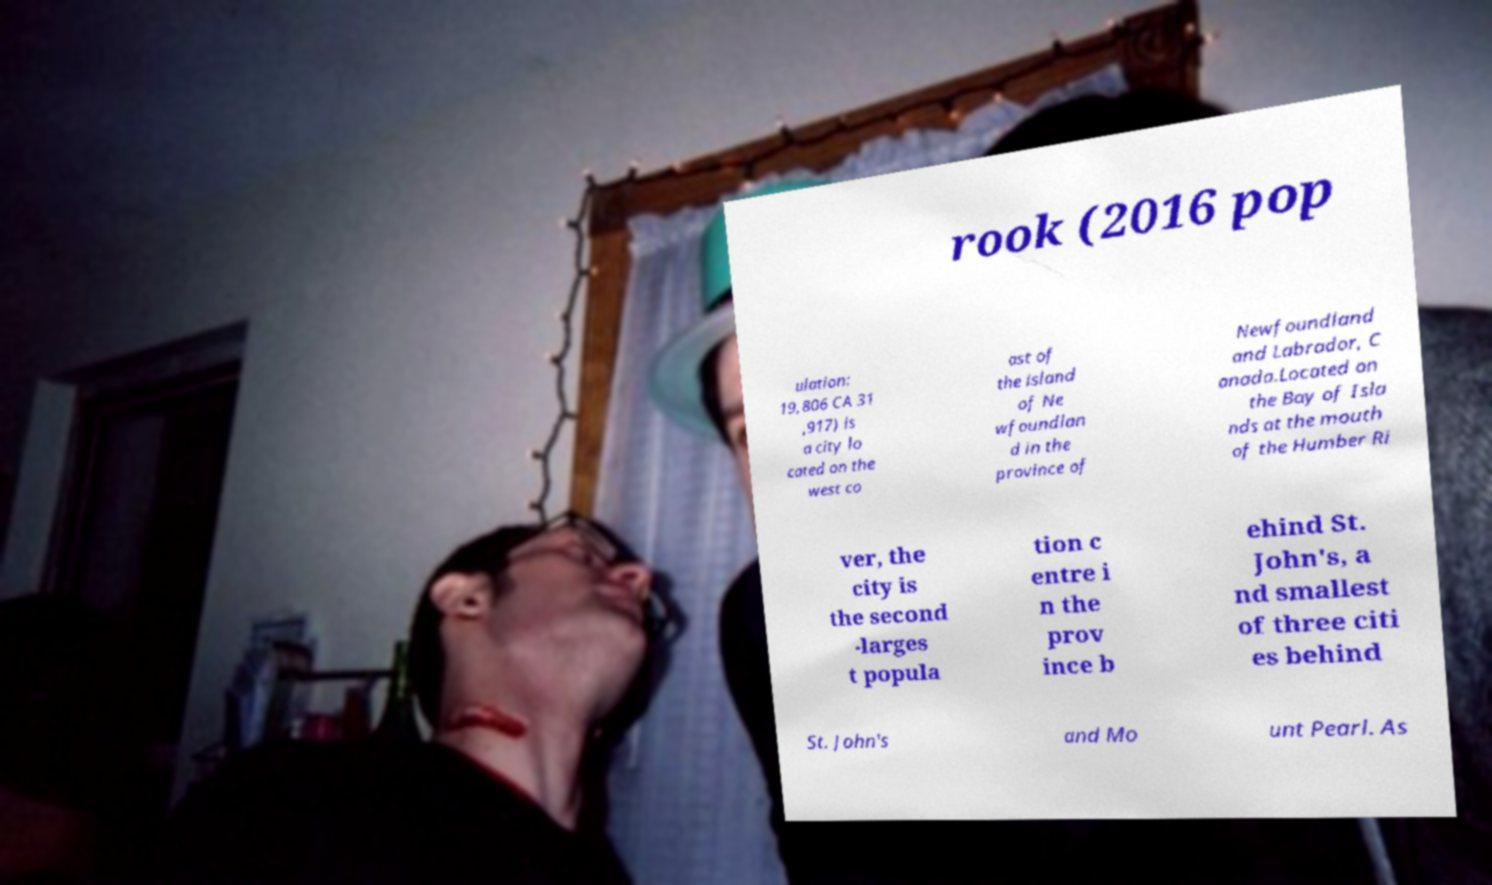For documentation purposes, I need the text within this image transcribed. Could you provide that? rook (2016 pop ulation: 19,806 CA 31 ,917) is a city lo cated on the west co ast of the island of Ne wfoundlan d in the province of Newfoundland and Labrador, C anada.Located on the Bay of Isla nds at the mouth of the Humber Ri ver, the city is the second -larges t popula tion c entre i n the prov ince b ehind St. John's, a nd smallest of three citi es behind St. John's and Mo unt Pearl. As 